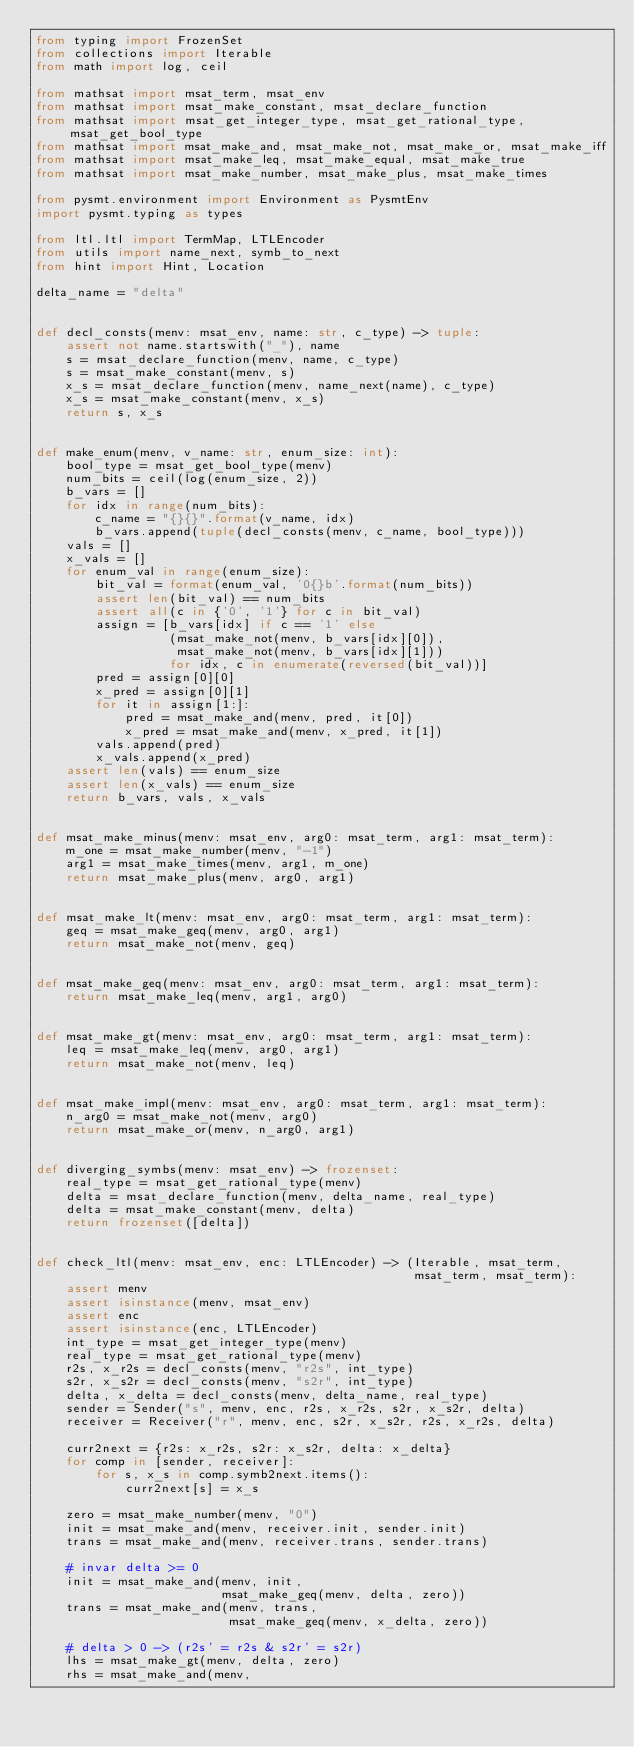<code> <loc_0><loc_0><loc_500><loc_500><_Python_>from typing import FrozenSet
from collections import Iterable
from math import log, ceil

from mathsat import msat_term, msat_env
from mathsat import msat_make_constant, msat_declare_function
from mathsat import msat_get_integer_type, msat_get_rational_type,     msat_get_bool_type
from mathsat import msat_make_and, msat_make_not, msat_make_or, msat_make_iff
from mathsat import msat_make_leq, msat_make_equal, msat_make_true
from mathsat import msat_make_number, msat_make_plus, msat_make_times

from pysmt.environment import Environment as PysmtEnv
import pysmt.typing as types

from ltl.ltl import TermMap, LTLEncoder
from utils import name_next, symb_to_next
from hint import Hint, Location

delta_name = "delta"


def decl_consts(menv: msat_env, name: str, c_type) -> tuple:
    assert not name.startswith("_"), name
    s = msat_declare_function(menv, name, c_type)
    s = msat_make_constant(menv, s)
    x_s = msat_declare_function(menv, name_next(name), c_type)
    x_s = msat_make_constant(menv, x_s)
    return s, x_s


def make_enum(menv, v_name: str, enum_size: int):
    bool_type = msat_get_bool_type(menv)
    num_bits = ceil(log(enum_size, 2))
    b_vars = []
    for idx in range(num_bits):
        c_name = "{}{}".format(v_name, idx)
        b_vars.append(tuple(decl_consts(menv, c_name, bool_type)))
    vals = []
    x_vals = []
    for enum_val in range(enum_size):
        bit_val = format(enum_val, '0{}b'.format(num_bits))
        assert len(bit_val) == num_bits
        assert all(c in {'0', '1'} for c in bit_val)
        assign = [b_vars[idx] if c == '1' else
                  (msat_make_not(menv, b_vars[idx][0]),
                   msat_make_not(menv, b_vars[idx][1]))
                  for idx, c in enumerate(reversed(bit_val))]
        pred = assign[0][0]
        x_pred = assign[0][1]
        for it in assign[1:]:
            pred = msat_make_and(menv, pred, it[0])
            x_pred = msat_make_and(menv, x_pred, it[1])
        vals.append(pred)
        x_vals.append(x_pred)
    assert len(vals) == enum_size
    assert len(x_vals) == enum_size
    return b_vars, vals, x_vals


def msat_make_minus(menv: msat_env, arg0: msat_term, arg1: msat_term):
    m_one = msat_make_number(menv, "-1")
    arg1 = msat_make_times(menv, arg1, m_one)
    return msat_make_plus(menv, arg0, arg1)


def msat_make_lt(menv: msat_env, arg0: msat_term, arg1: msat_term):
    geq = msat_make_geq(menv, arg0, arg1)
    return msat_make_not(menv, geq)


def msat_make_geq(menv: msat_env, arg0: msat_term, arg1: msat_term):
    return msat_make_leq(menv, arg1, arg0)


def msat_make_gt(menv: msat_env, arg0: msat_term, arg1: msat_term):
    leq = msat_make_leq(menv, arg0, arg1)
    return msat_make_not(menv, leq)


def msat_make_impl(menv: msat_env, arg0: msat_term, arg1: msat_term):
    n_arg0 = msat_make_not(menv, arg0)
    return msat_make_or(menv, n_arg0, arg1)


def diverging_symbs(menv: msat_env) -> frozenset:
    real_type = msat_get_rational_type(menv)
    delta = msat_declare_function(menv, delta_name, real_type)
    delta = msat_make_constant(menv, delta)
    return frozenset([delta])


def check_ltl(menv: msat_env, enc: LTLEncoder) -> (Iterable, msat_term,
                                                   msat_term, msat_term):
    assert menv
    assert isinstance(menv, msat_env)
    assert enc
    assert isinstance(enc, LTLEncoder)
    int_type = msat_get_integer_type(menv)
    real_type = msat_get_rational_type(menv)
    r2s, x_r2s = decl_consts(menv, "r2s", int_type)
    s2r, x_s2r = decl_consts(menv, "s2r", int_type)
    delta, x_delta = decl_consts(menv, delta_name, real_type)
    sender = Sender("s", menv, enc, r2s, x_r2s, s2r, x_s2r, delta)
    receiver = Receiver("r", menv, enc, s2r, x_s2r, r2s, x_r2s, delta)

    curr2next = {r2s: x_r2s, s2r: x_s2r, delta: x_delta}
    for comp in [sender, receiver]:
        for s, x_s in comp.symb2next.items():
            curr2next[s] = x_s

    zero = msat_make_number(menv, "0")
    init = msat_make_and(menv, receiver.init, sender.init)
    trans = msat_make_and(menv, receiver.trans, sender.trans)

    # invar delta >= 0
    init = msat_make_and(menv, init,
                         msat_make_geq(menv, delta, zero))
    trans = msat_make_and(menv, trans,
                          msat_make_geq(menv, x_delta, zero))

    # delta > 0 -> (r2s' = r2s & s2r' = s2r)
    lhs = msat_make_gt(menv, delta, zero)
    rhs = msat_make_and(menv,</code> 